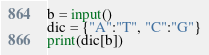Convert code to text. <code><loc_0><loc_0><loc_500><loc_500><_Python_>b = input()
dic = {"A":"T", "C":"G"}
print(dic[b])</code> 